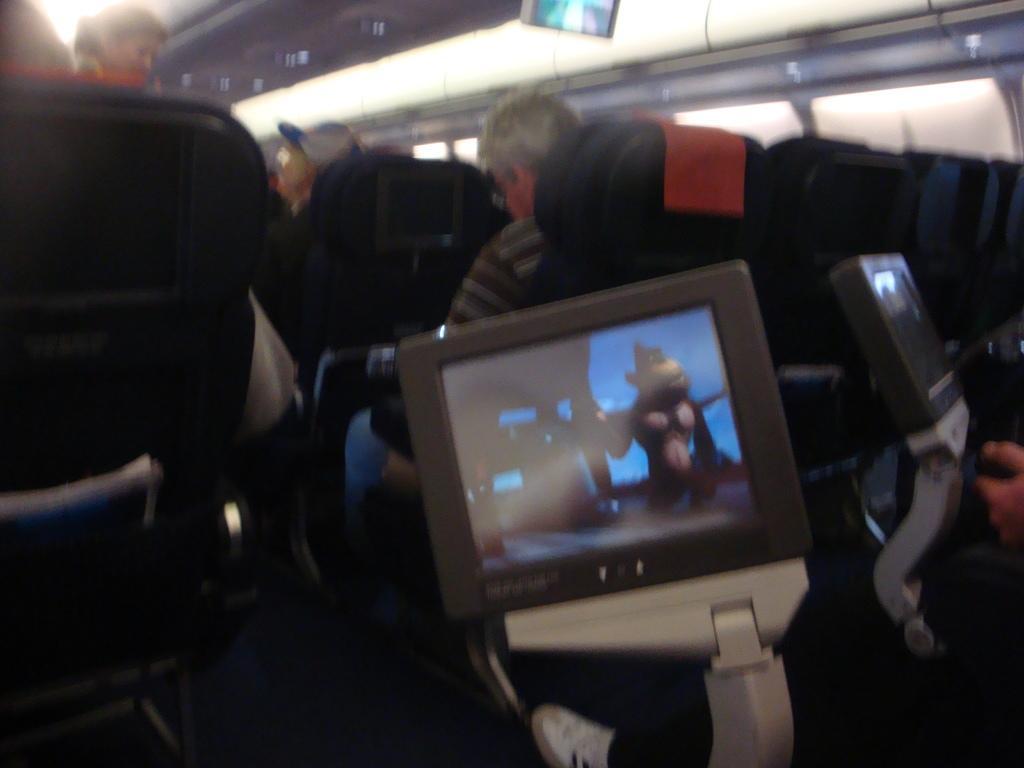Please provide a concise description of this image. In this picture we can see television screen. Here we can see an old man who is wearing spectacle, t-shirt and jeans, sitting on the chair. On the top left corner we can see a woman who is standing beside the seats. Here we can see a man who is looking to her. On the top right corner there is a window. 